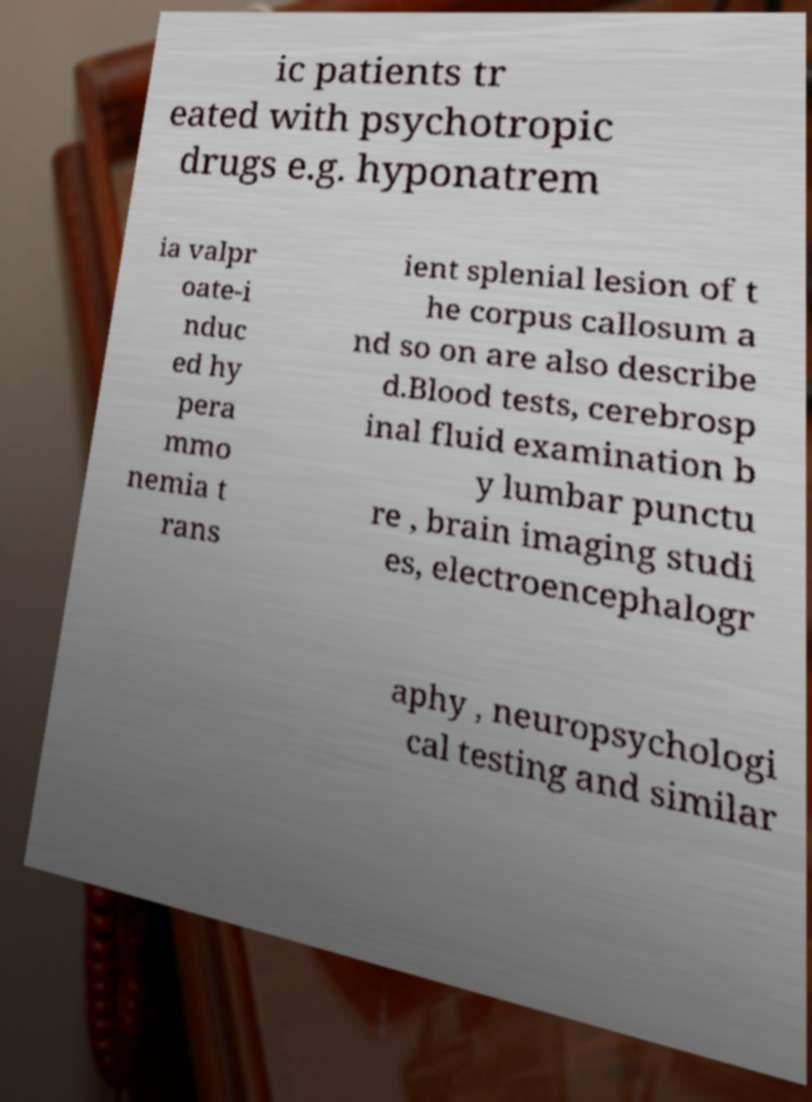What messages or text are displayed in this image? I need them in a readable, typed format. ic patients tr eated with psychotropic drugs e.g. hyponatrem ia valpr oate-i nduc ed hy pera mmo nemia t rans ient splenial lesion of t he corpus callosum a nd so on are also describe d.Blood tests, cerebrosp inal fluid examination b y lumbar punctu re , brain imaging studi es, electroencephalogr aphy , neuropsychologi cal testing and similar 